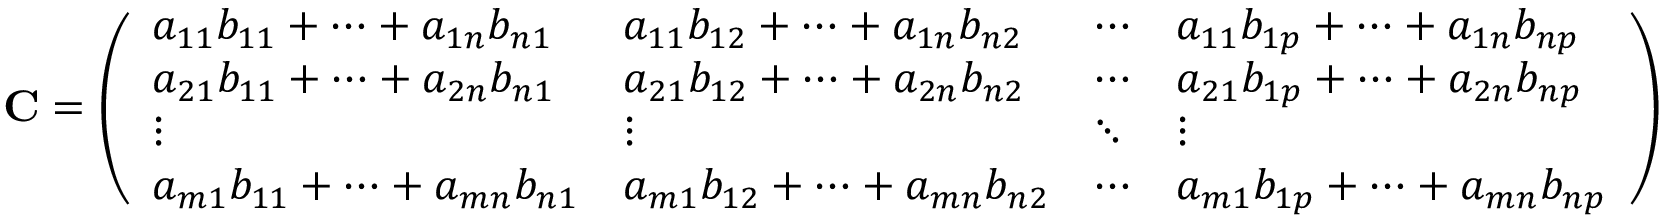<formula> <loc_0><loc_0><loc_500><loc_500>C = { \left ( \begin{array} { l l l l } { a _ { 1 1 } b _ { 1 1 } + \cdots + a _ { 1 n } b _ { n 1 } } & { a _ { 1 1 } b _ { 1 2 } + \cdots + a _ { 1 n } b _ { n 2 } } & { \cdots } & { a _ { 1 1 } b _ { 1 p } + \cdots + a _ { 1 n } b _ { n p } } \\ { a _ { 2 1 } b _ { 1 1 } + \cdots + a _ { 2 n } b _ { n 1 } } & { a _ { 2 1 } b _ { 1 2 } + \cdots + a _ { 2 n } b _ { n 2 } } & { \cdots } & { a _ { 2 1 } b _ { 1 p } + \cdots + a _ { 2 n } b _ { n p } } \\ { \vdots } & { \vdots } & { \ddots } & { \vdots } \\ { a _ { m 1 } b _ { 1 1 } + \cdots + a _ { m n } b _ { n 1 } } & { a _ { m 1 } b _ { 1 2 } + \cdots + a _ { m n } b _ { n 2 } } & { \cdots } & { a _ { m 1 } b _ { 1 p } + \cdots + a _ { m n } b _ { n p } } \end{array} \right ) }</formula> 